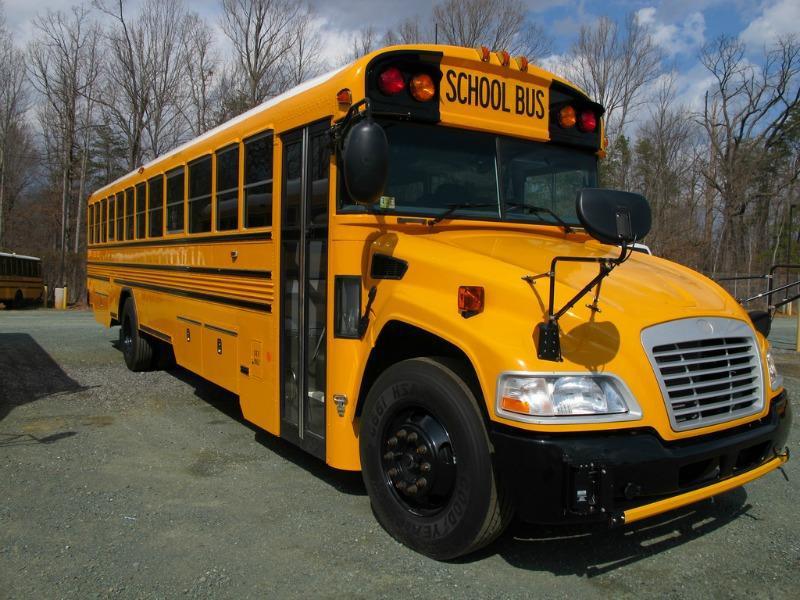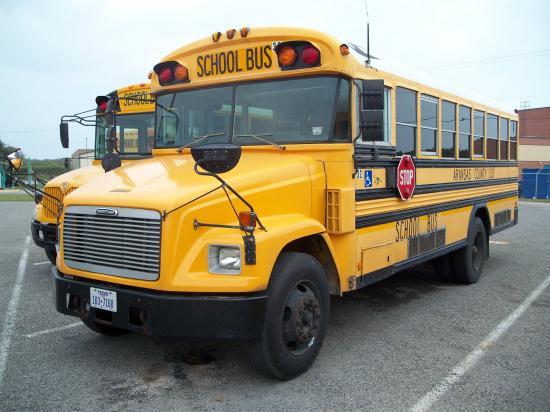The first image is the image on the left, the second image is the image on the right. Considering the images on both sides, is "All the school buses in the images are facing to the left." valid? Answer yes or no. No. The first image is the image on the left, the second image is the image on the right. Given the left and right images, does the statement "One of the images features two school buses beside each other." hold true? Answer yes or no. Yes. 